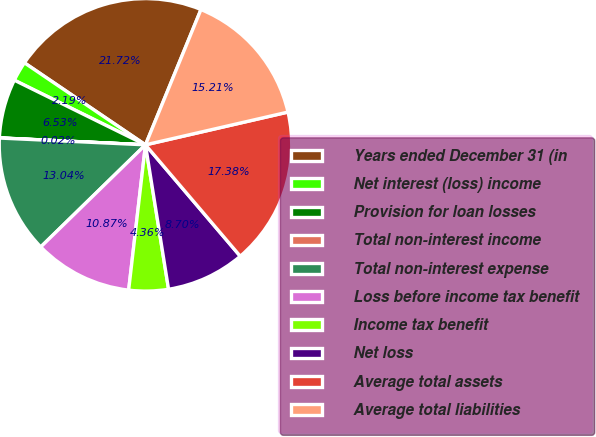Convert chart to OTSL. <chart><loc_0><loc_0><loc_500><loc_500><pie_chart><fcel>Years ended December 31 (in<fcel>Net interest (loss) income<fcel>Provision for loan losses<fcel>Total non-interest income<fcel>Total non-interest expense<fcel>Loss before income tax benefit<fcel>Income tax benefit<fcel>Net loss<fcel>Average total assets<fcel>Average total liabilities<nl><fcel>21.72%<fcel>2.19%<fcel>6.53%<fcel>0.02%<fcel>13.04%<fcel>10.87%<fcel>4.36%<fcel>8.7%<fcel>17.38%<fcel>15.21%<nl></chart> 